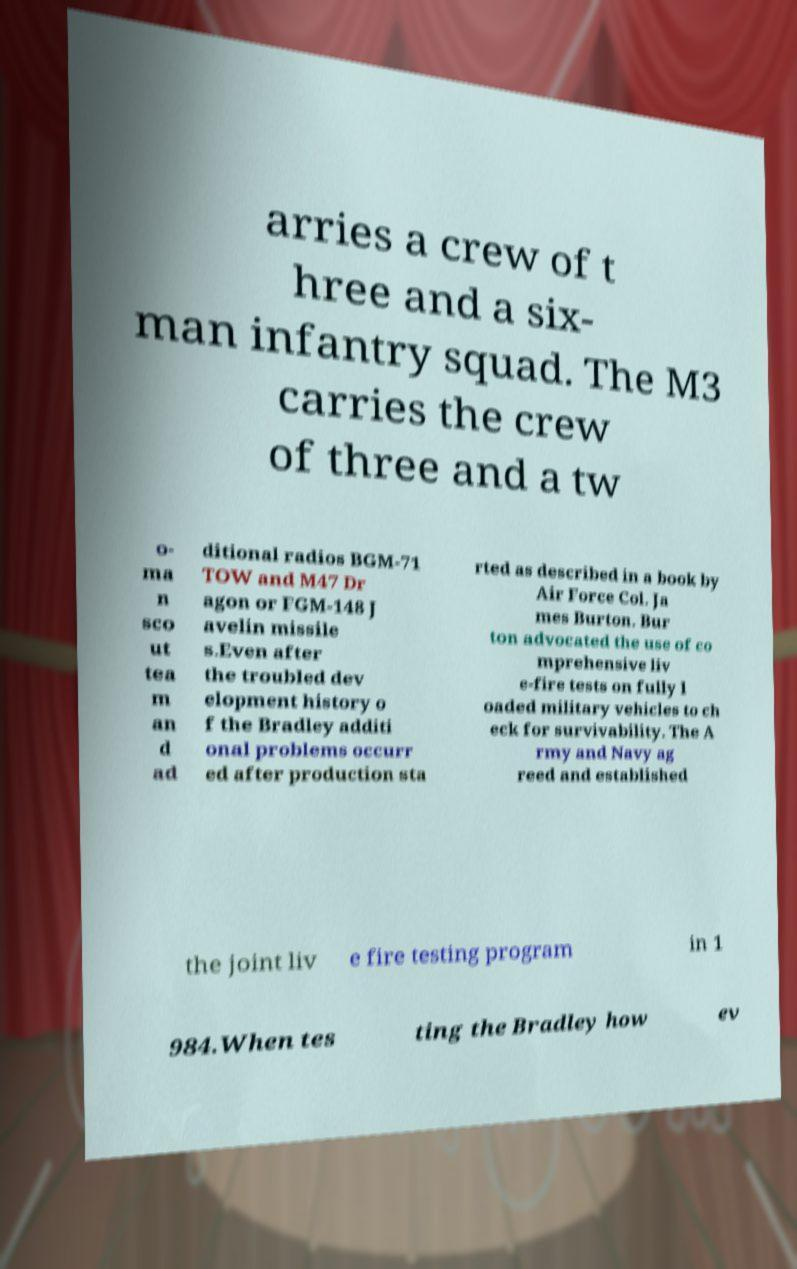Could you extract and type out the text from this image? arries a crew of t hree and a six- man infantry squad. The M3 carries the crew of three and a tw o- ma n sco ut tea m an d ad ditional radios BGM-71 TOW and M47 Dr agon or FGM-148 J avelin missile s.Even after the troubled dev elopment history o f the Bradley additi onal problems occurr ed after production sta rted as described in a book by Air Force Col. Ja mes Burton. Bur ton advocated the use of co mprehensive liv e-fire tests on fully l oaded military vehicles to ch eck for survivability. The A rmy and Navy ag reed and established the joint liv e fire testing program in 1 984.When tes ting the Bradley how ev 